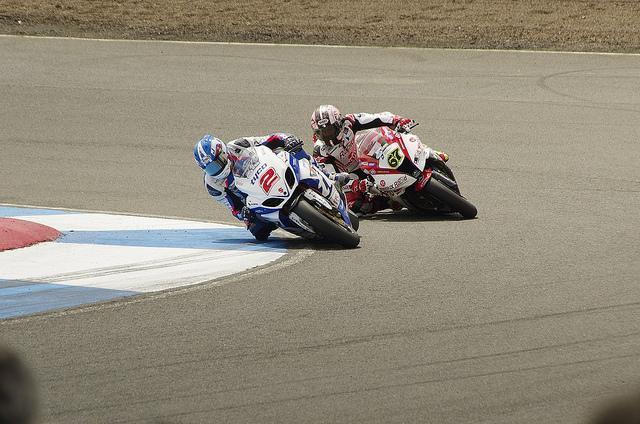How many people are in the photo?
Give a very brief answer. 2. How many motorcycles are there?
Give a very brief answer. 2. How many boats do you see?
Give a very brief answer. 0. 